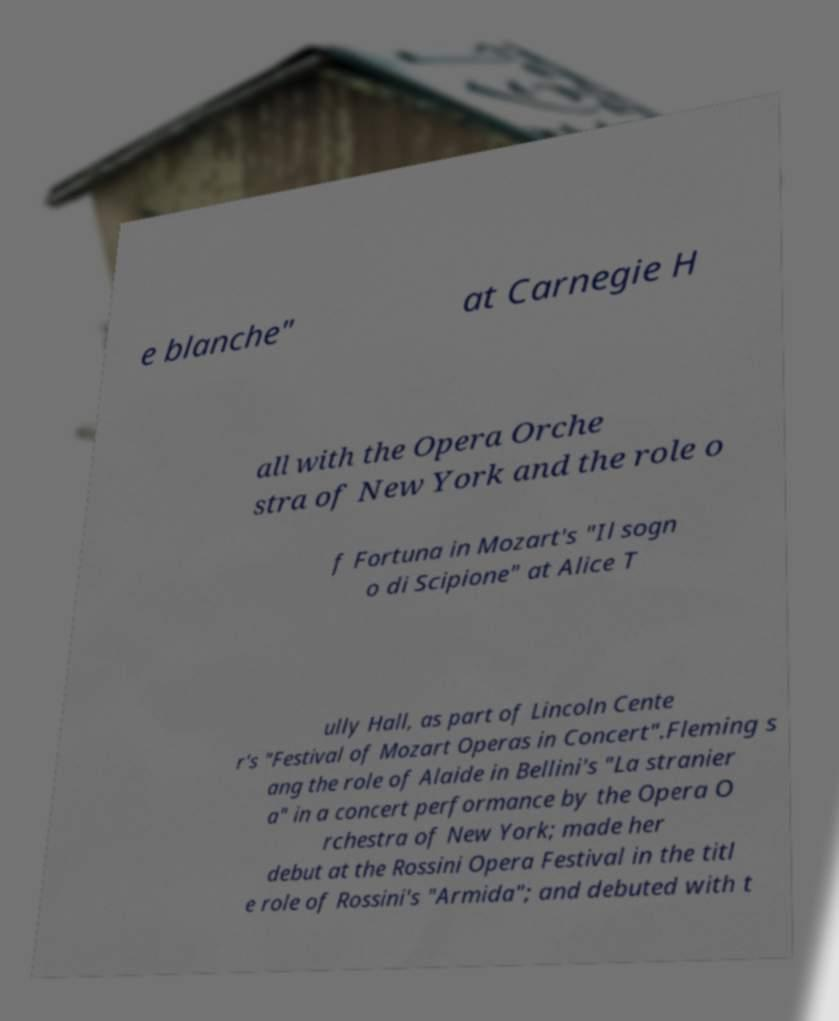Can you read and provide the text displayed in the image?This photo seems to have some interesting text. Can you extract and type it out for me? e blanche" at Carnegie H all with the Opera Orche stra of New York and the role o f Fortuna in Mozart's "Il sogn o di Scipione" at Alice T ully Hall, as part of Lincoln Cente r's "Festival of Mozart Operas in Concert".Fleming s ang the role of Alaide in Bellini's "La stranier a" in a concert performance by the Opera O rchestra of New York; made her debut at the Rossini Opera Festival in the titl e role of Rossini's "Armida"; and debuted with t 